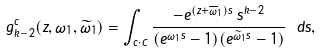<formula> <loc_0><loc_0><loc_500><loc_500>g ^ { c } _ { k - 2 } ( z , \omega _ { 1 } , \widetilde { \omega } _ { 1 } ) = \int _ { c \cdot C } \frac { - e ^ { ( z + \overline { \omega } _ { 1 } ) s } \, s ^ { k - 2 } } { ( e ^ { \omega _ { 1 } s } - 1 ) ( e ^ { \widetilde { \omega } _ { 1 } s } - 1 ) } \ d s ,</formula> 